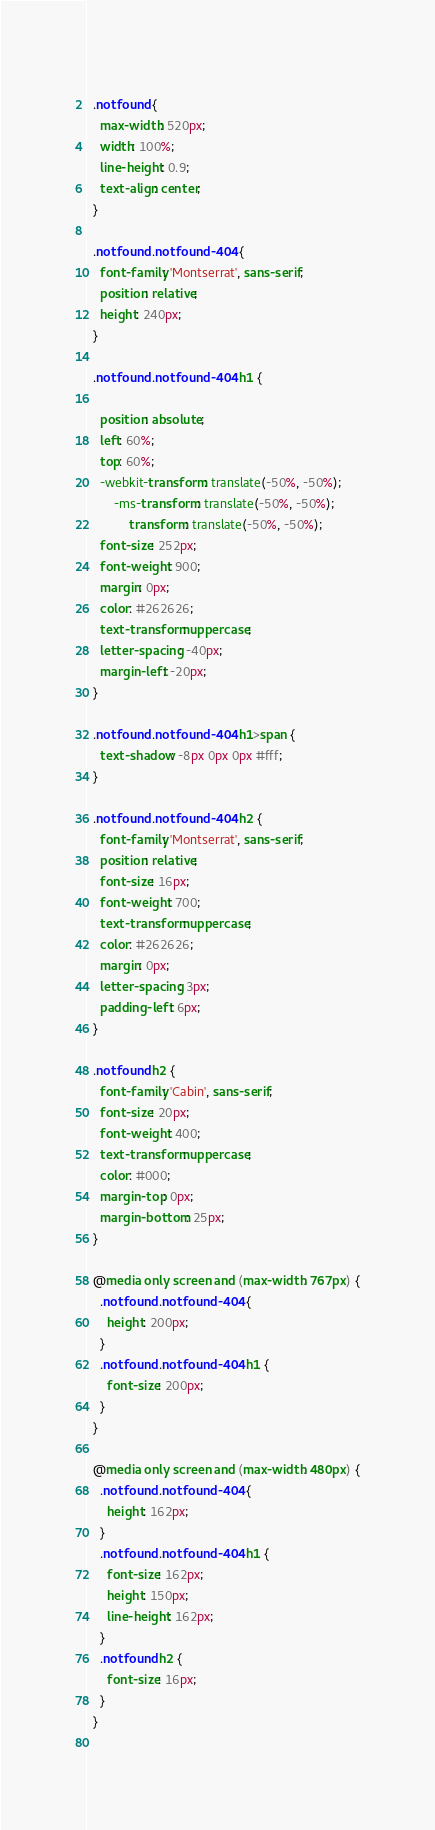Convert code to text. <code><loc_0><loc_0><loc_500><loc_500><_CSS_>  
  .notfound {
    max-width: 520px;
    width: 100%;
    line-height: 0.9;
    text-align: center;
  }
  
  .notfound .notfound-404 {
    font-family: 'Montserrat', sans-serif;
    position: relative;
    height: 240px;
  }
  
  .notfound .notfound-404 h1 {
    
    position: absolute;
    left: 60%;
    top: 60%;
    -webkit-transform: translate(-50%, -50%);
        -ms-transform: translate(-50%, -50%);
            transform: translate(-50%, -50%);
    font-size: 252px;
    font-weight: 900;
    margin: 0px;
    color: #262626;
    text-transform: uppercase;
    letter-spacing: -40px;
    margin-left: -20px;
  }
  
  .notfound .notfound-404 h1>span {
    text-shadow: -8px 0px 0px #fff;
  }
  
  .notfound .notfound-404 h2 {
    font-family: 'Montserrat', sans-serif;
    position: relative;
    font-size: 16px;
    font-weight: 700;
    text-transform: uppercase;
    color: #262626;
    margin: 0px;
    letter-spacing: 3px;
    padding-left: 6px;
  }
  
  .notfound h2 {
    font-family: 'Cabin', sans-serif;
    font-size: 20px;
    font-weight: 400;
    text-transform: uppercase;
    color: #000;
    margin-top: 0px;
    margin-bottom: 25px;
  }
  
  @media only screen and (max-width: 767px) {
    .notfound .notfound-404 {
      height: 200px;
    }
    .notfound .notfound-404 h1 {
      font-size: 200px;
    }
  }
  
  @media only screen and (max-width: 480px) {
    .notfound .notfound-404 {
      height: 162px;
    }
    .notfound .notfound-404 h1 {
      font-size: 162px;
      height: 150px;
      line-height: 162px;
    }
    .notfound h2 {
      font-size: 16px;
    }
  }
  </code> 